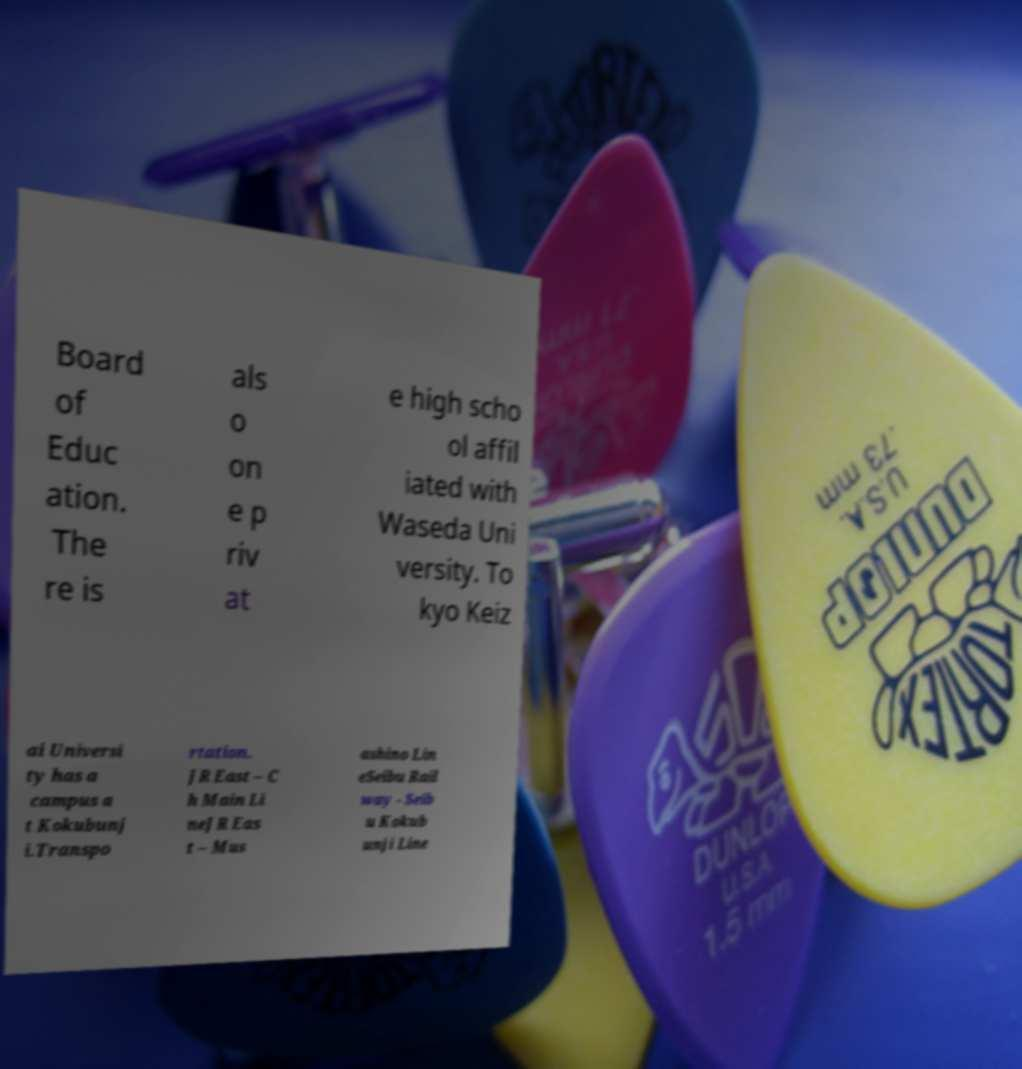Please identify and transcribe the text found in this image. Board of Educ ation. The re is als o on e p riv at e high scho ol affil iated with Waseda Uni versity. To kyo Keiz ai Universi ty has a campus a t Kokubunj i.Transpo rtation. JR East – C h Main Li neJR Eas t – Mus ashino Lin eSeibu Rail way - Seib u Kokub unji Line 